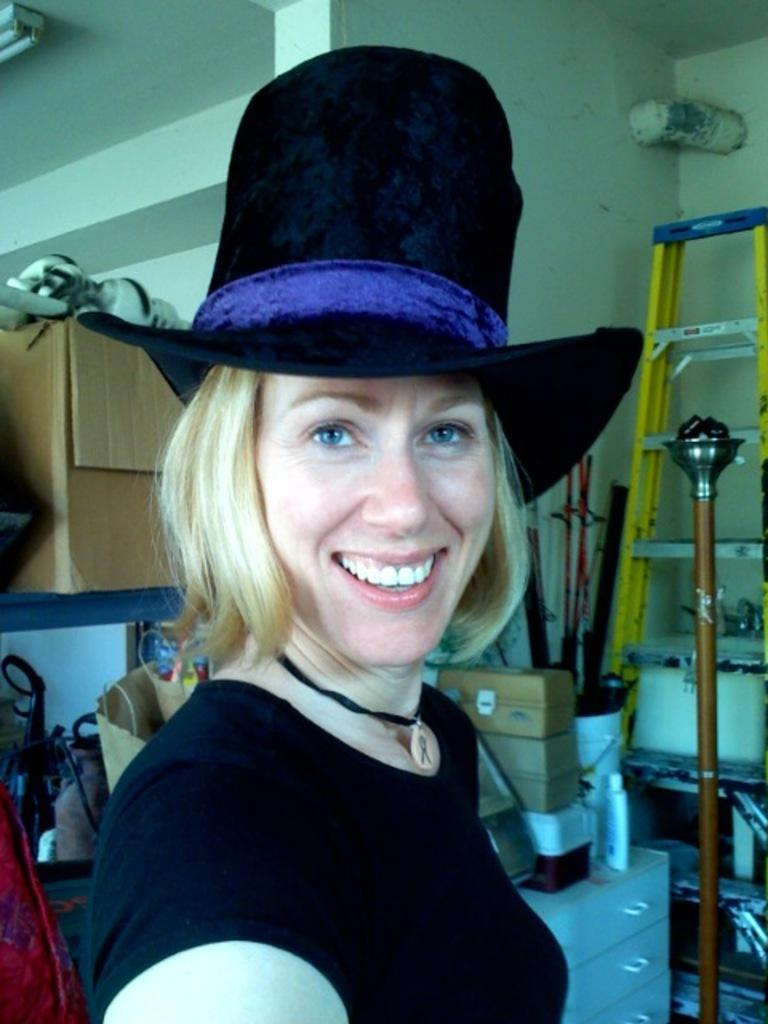Who is present in the image? There is a woman in the image. What is the woman doing in the image? The woman is smiling in the image. What is the woman wearing on her head? The woman is wearing a cap in the image. What type of objects can be seen in the image? There are boxes, a ladder, and metal rods visible in the image. Can you describe the other unspecified objects in the image? Unfortunately, the facts provided do not specify the nature of the other unspecified objects in the image. How many cubs are visible in the image? A: There are no cubs present in the image. What type of ear is visible on the woman in the image? The facts provided do not mention any ears or specific ear types; the woman is only described as wearing a cap and smiling. 